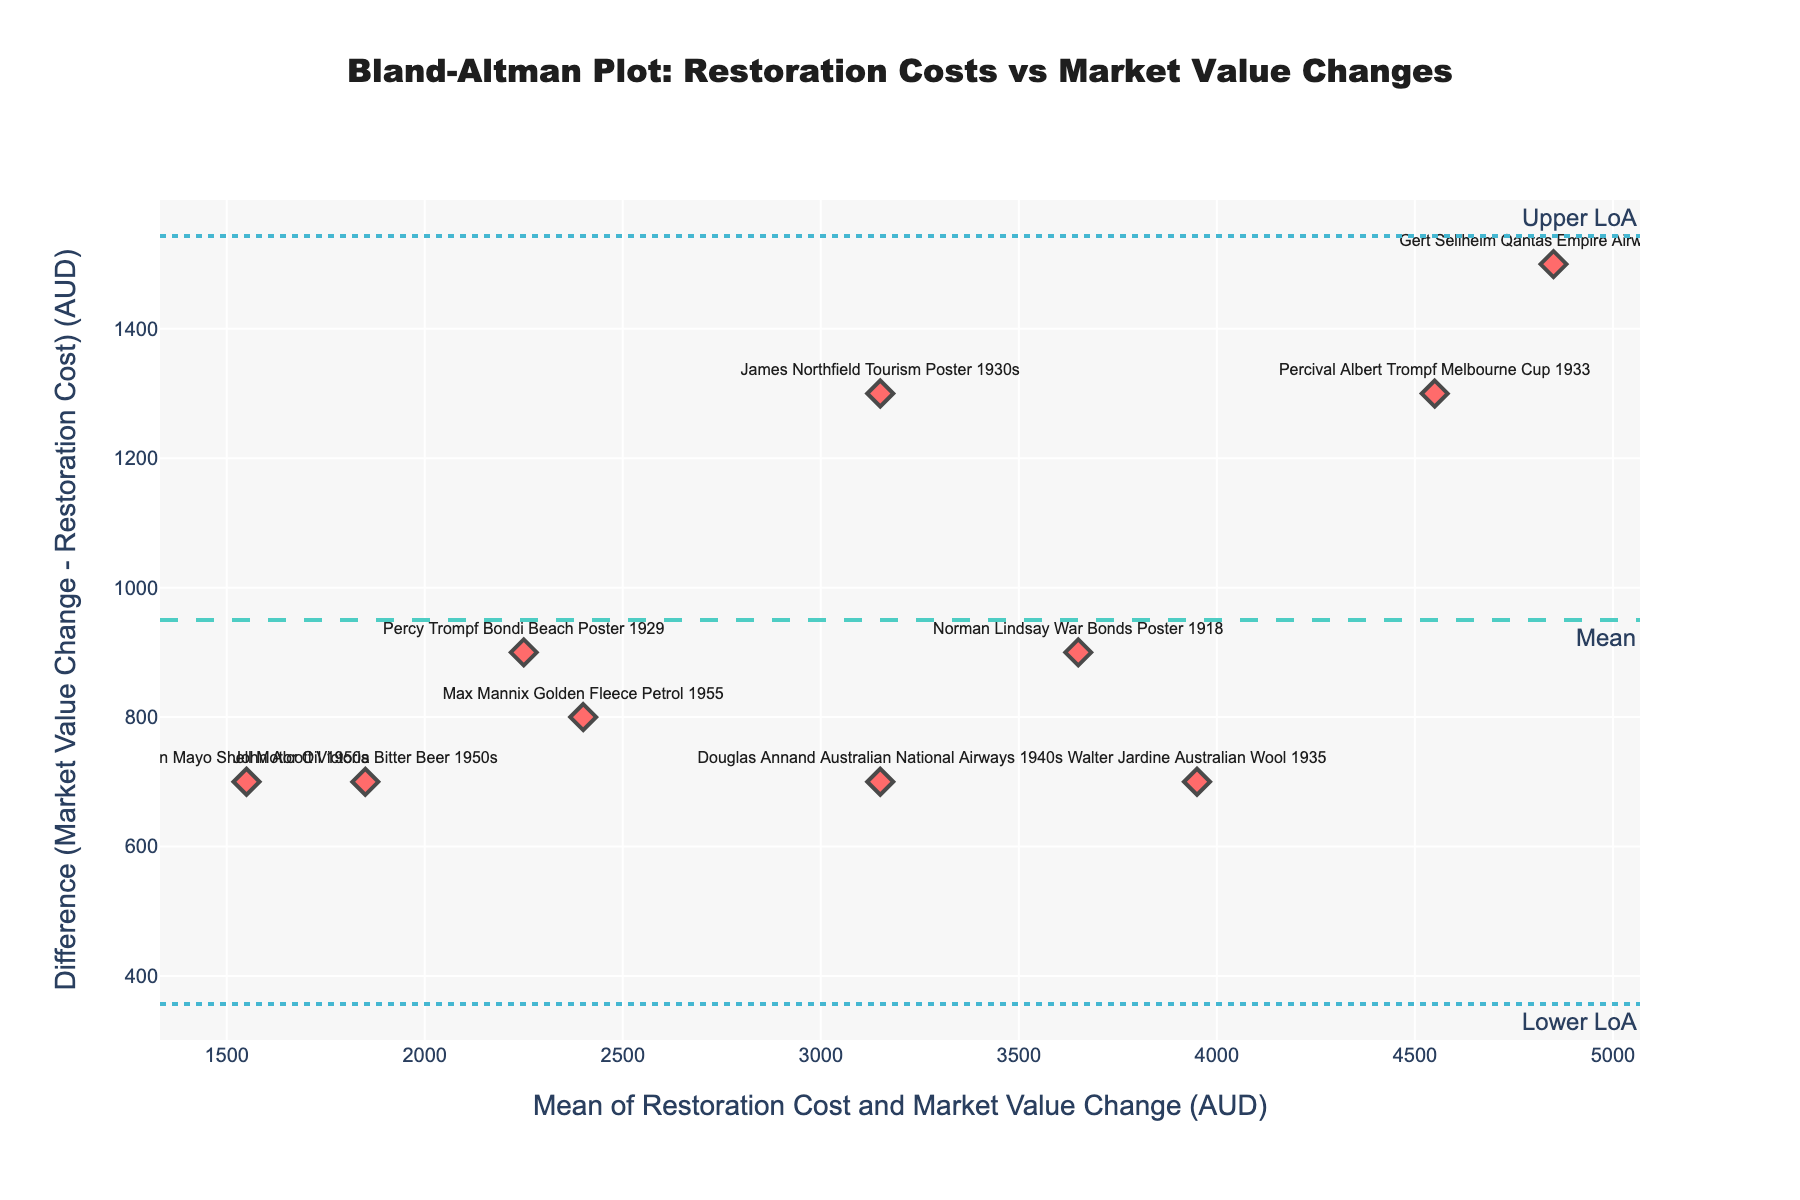What is the title of the figure? The title is typically placed at the top of the figure. In this case, the title "Bland-Altman Plot: Restoration Costs vs Market Value Changes" is clearly displayed at the top.
Answer: Bland-Altman Plot: Restoration Costs vs Market Value Changes How many data points are plotted in the figure? By counting the markers, you can see that there are ten data points plotted, each representing a different vintage Australian advertising poster.
Answer: 10 Which poster has the highest mean value of Restoration Cost and Market Value Change? To find this, identify the data point with the highest x-axis value. The "Percival Albert Trompf Melbourne Cup 1933" poster has the highest mean value.
Answer: Percival Albert Trompf Melbourne Cup 1933 What colors are used for the scatter plot markers and the mean line? The scatter plot markers are colored red, and the mean line is colored cyan with a dashed pattern.
Answer: Red and cyan What is the mean difference between the Market Value Change and the Restoration Cost? The mean difference is represented by the dashed line labeled "Mean" on the plot. It is located around 1450 AUD.
Answer: 1450 AUD Which poster shows the smallest difference between Market Value Change and Restoration Cost? By looking at the y-axis values closest to zero, the "Percy Trompf Bondi Beach Poster 1929" has the smallest difference.
Answer: Percy Trompf Bondi Beach Poster 1929 How can you describe the general relationship between Restoration Costs and Market Value Changes based on the plot? The scatter plot shows that most data points are above the mean difference line, suggesting that in most cases, the Market Value Change exceeds the Restoration Cost.
Answer: Market Value Change generally exceeds Restoration Cost Are there any posters where Restoration Cost is higher than the Market Value Change? To determine this, look for data points below the mean difference line. All data points are above the line, indicating no cases where Restoration Cost is higher.
Answer: No What are the upper and lower Limits of Agreement (LoA) values, and how do they guide the interpretation of the plot? The Upper LoA and Lower LoA are indicated by dotted lines on the plot. These lines help identify the range within which most differences between Market Value Change and Restoration Cost lie. The Upper LoA is about 2460 AUD, and the Lower LoA is around 440 AUD.
Answer: Upper LoA: 2460 AUD, Lower LoA: 440 AUD Which poster has the largest deviation from the mean difference? The poster with the highest y-axis value, "John Alcott Victoria Bitter Beer 1950s," has the largest deviation from the mean difference.
Answer: John Alcott Victoria Bitter Beer 1950s 